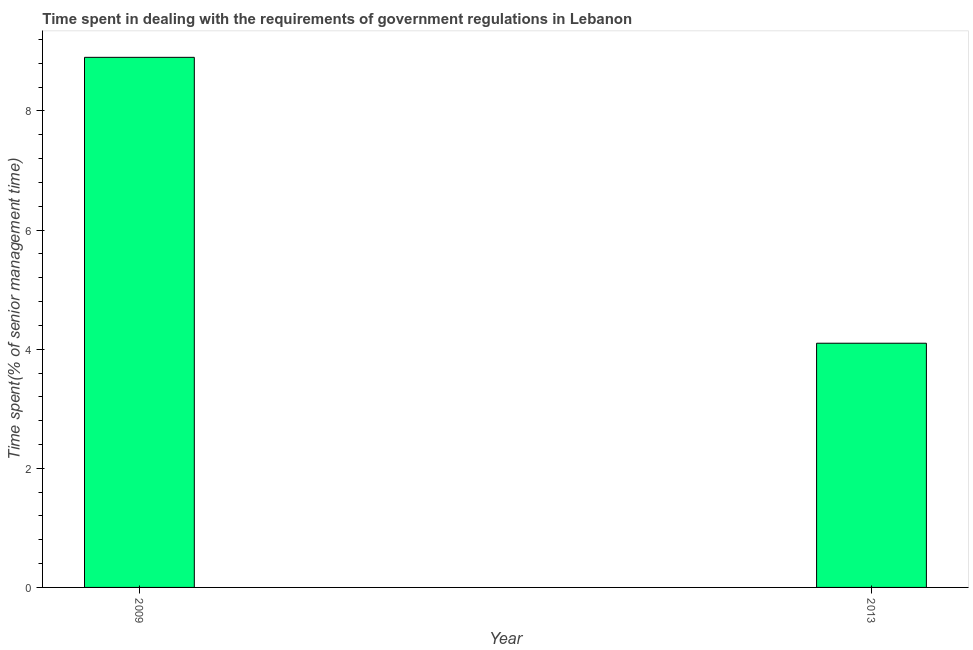What is the title of the graph?
Give a very brief answer. Time spent in dealing with the requirements of government regulations in Lebanon. What is the label or title of the Y-axis?
Ensure brevity in your answer.  Time spent(% of senior management time). What is the time spent in dealing with government regulations in 2009?
Your response must be concise. 8.9. Across all years, what is the minimum time spent in dealing with government regulations?
Make the answer very short. 4.1. In which year was the time spent in dealing with government regulations maximum?
Keep it short and to the point. 2009. In which year was the time spent in dealing with government regulations minimum?
Ensure brevity in your answer.  2013. What is the sum of the time spent in dealing with government regulations?
Make the answer very short. 13. What is the difference between the time spent in dealing with government regulations in 2009 and 2013?
Your response must be concise. 4.8. What is the average time spent in dealing with government regulations per year?
Keep it short and to the point. 6.5. What is the median time spent in dealing with government regulations?
Provide a succinct answer. 6.5. Do a majority of the years between 2009 and 2013 (inclusive) have time spent in dealing with government regulations greater than 0.8 %?
Provide a succinct answer. Yes. What is the ratio of the time spent in dealing with government regulations in 2009 to that in 2013?
Your answer should be compact. 2.17. In how many years, is the time spent in dealing with government regulations greater than the average time spent in dealing with government regulations taken over all years?
Provide a succinct answer. 1. How many bars are there?
Offer a terse response. 2. Are the values on the major ticks of Y-axis written in scientific E-notation?
Ensure brevity in your answer.  No. What is the ratio of the Time spent(% of senior management time) in 2009 to that in 2013?
Make the answer very short. 2.17. 